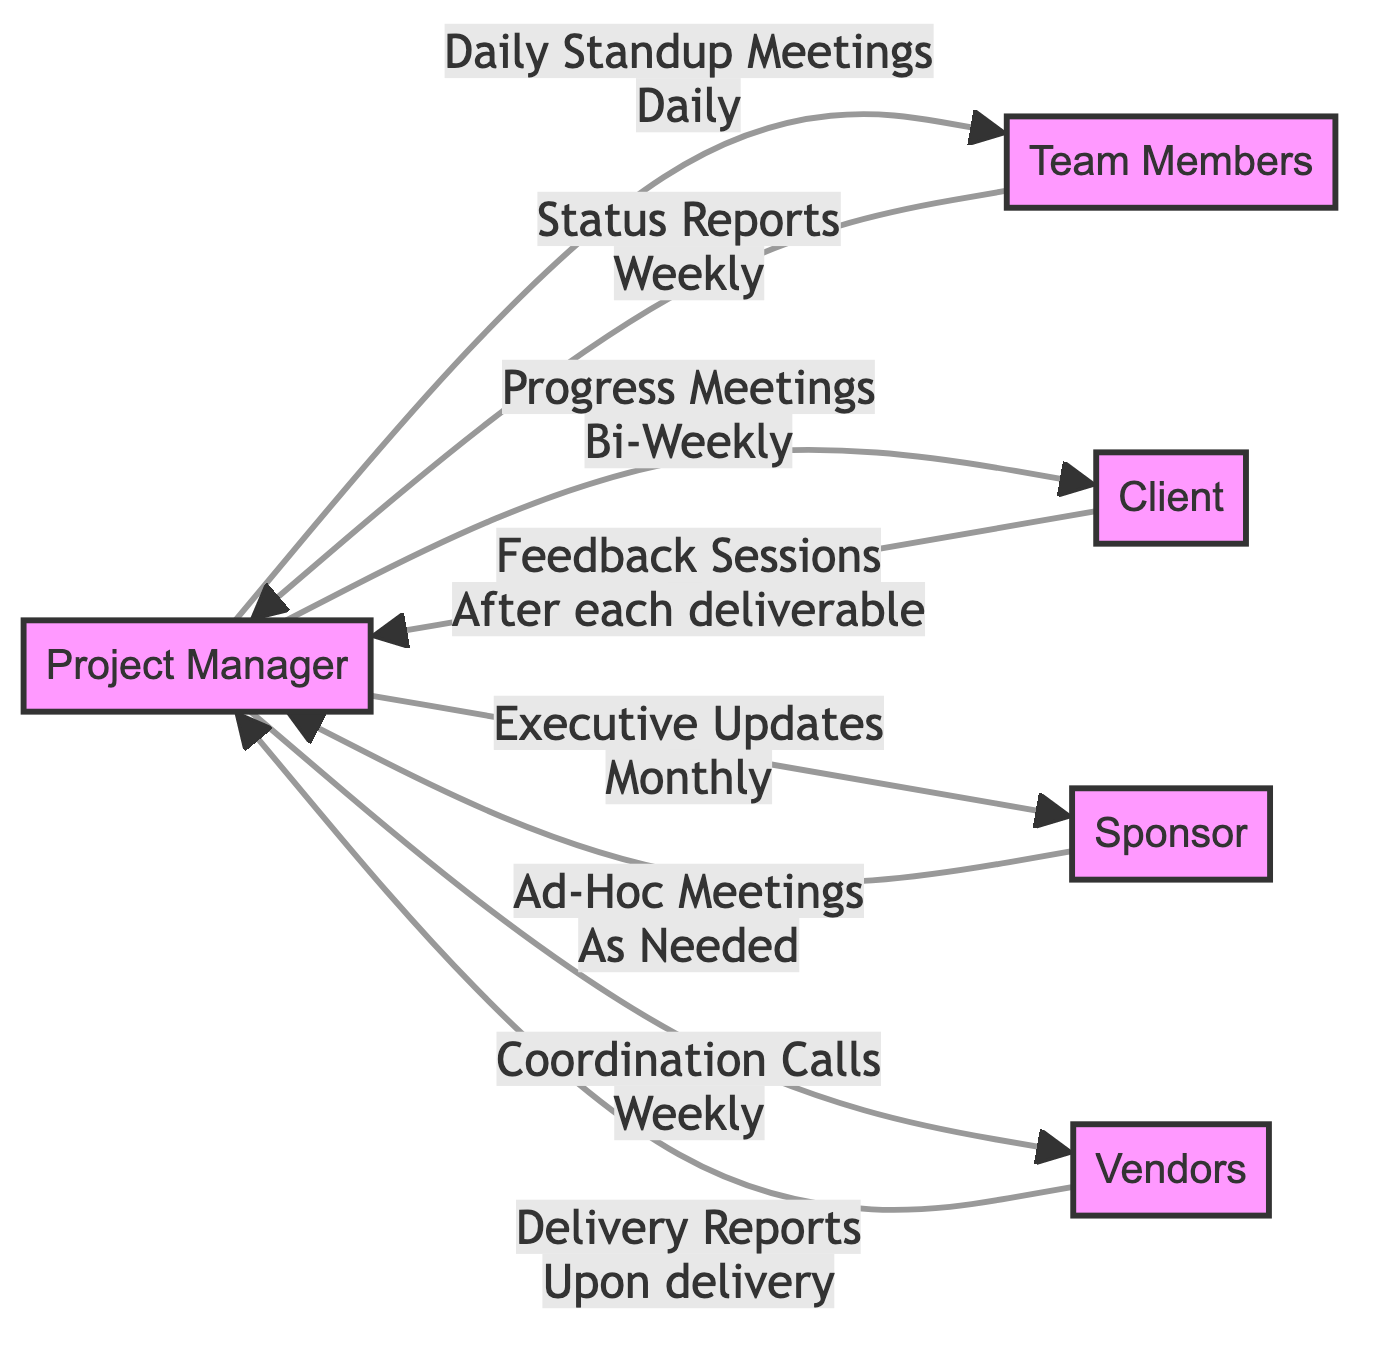What is the role of the Project Manager? The Project Manager is responsible for ensuring project timelines and deliverables are met and coordinating communication with all stakeholders.
Answer: Ensure project timelines and deliverables are met, and coordinate communication with all stakeholders How often do Team Members report status to the Project Manager? Team Members report their status to the Project Manager on a weekly basis, as indicated by the edge labeled "Status Reports."
Answer: Weekly What method does the Project Manager use to communicate with the Client? The Project Manager uses "Progress Meetings" to communicate with the Client, as shown on the corresponding edge.
Answer: Progress Meetings How many nodes are there in this directed graph? The diagram features five nodes: Project Manager, Team Members, Client, Sponsor, and Vendors; thereby, the count is five.
Answer: Five What is the frequency of coordination calls between the Project Manager and Vendors? The frequency of coordination calls between the Project Manager and Vendors is weekly, as specified on the edge that links them.
Answer: Weekly What type of communication does the Sponsor have with the Project Manager? The Sponsor communicates with the Project Manager through "Ad-Hoc Meetings," indicated by the edge connecting them.
Answer: Ad-Hoc Meetings During which meetings does the Client provide feedback? The Client provides feedback during "Feedback Sessions" which occur after each deliverable, as outlined in the diagram.
Answer: After each deliverable Which stakeholder provides financial support for the project? The stakeholder that provides financial support for the project is the Sponsor, as stated in the Role section of the diagram.
Answer: Sponsor What method of communication occurs upon the delivery of products from Vendors? The method of communication occurring upon the delivery of products from Vendors is "Delivery Reports," marked on the relevant edge of the graph.
Answer: Delivery Reports 